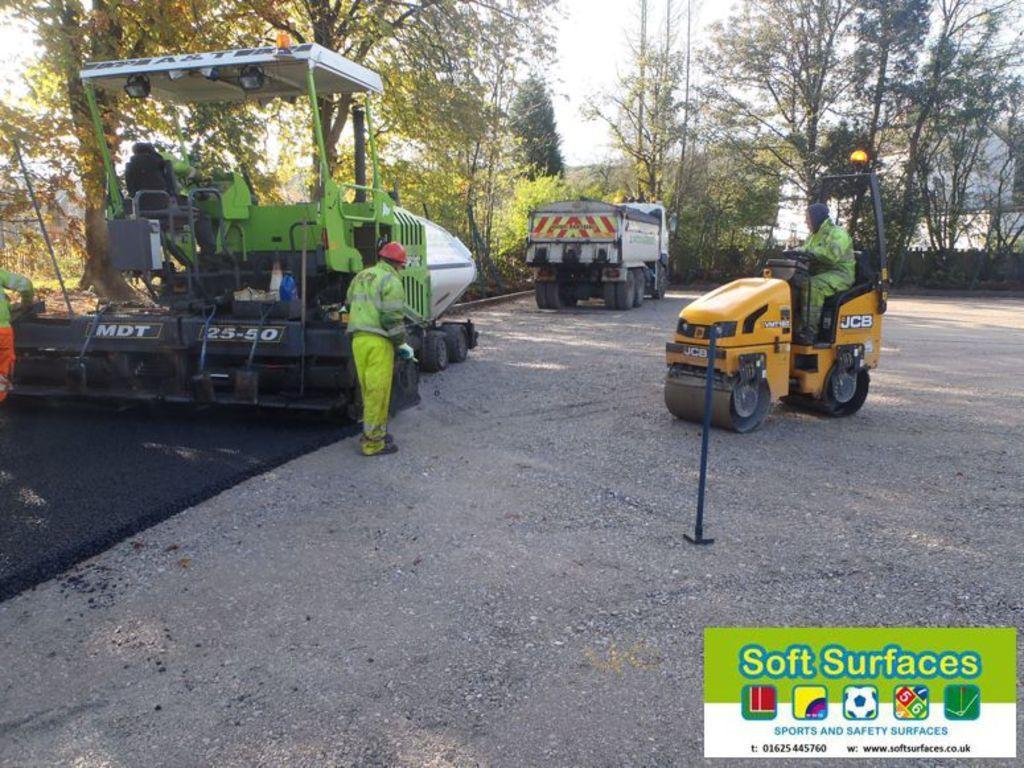Could you give a brief overview of what you see in this image? In this picture, we see a paver is laying the bitumen or asphalt on the road. Beside that, we see two men are standing. At the bottom, we see the road. On the right side, we see a man is riding an orange vehicle. We see a white color vehicle. There are trees and the buildings in the background. In the right bottom, we see a poster in white and green color with some text written on it. 